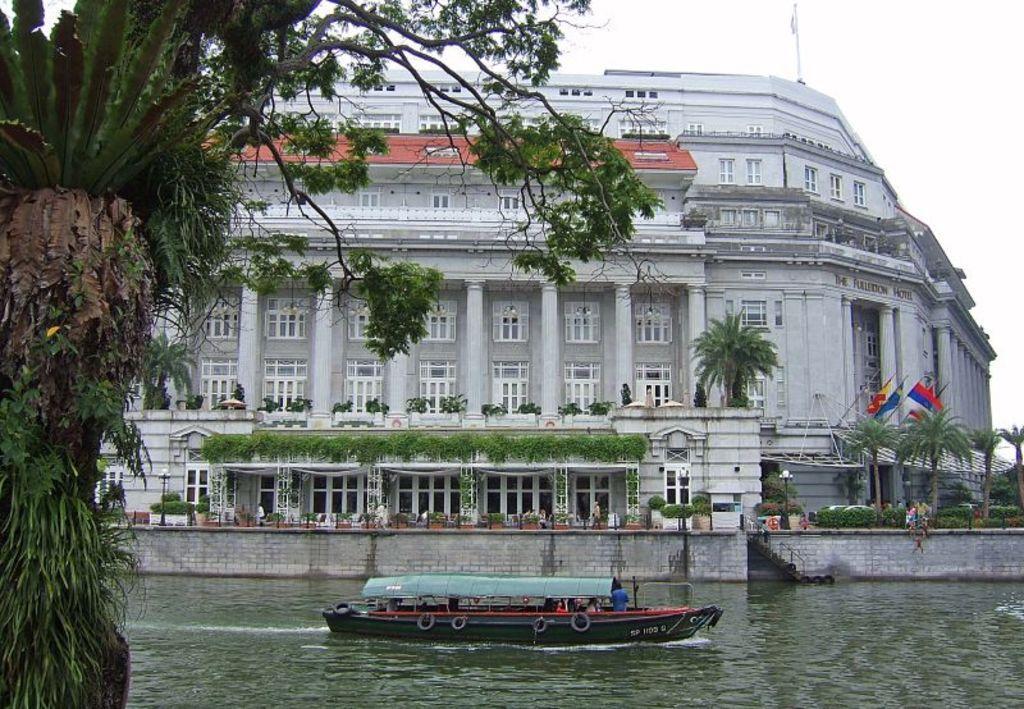In one or two sentences, can you explain what this image depicts? In this picture I can see the boat on the water. I can see the flags on the right side. I can see the building. I can see trees. I can see clouds in the sky. 